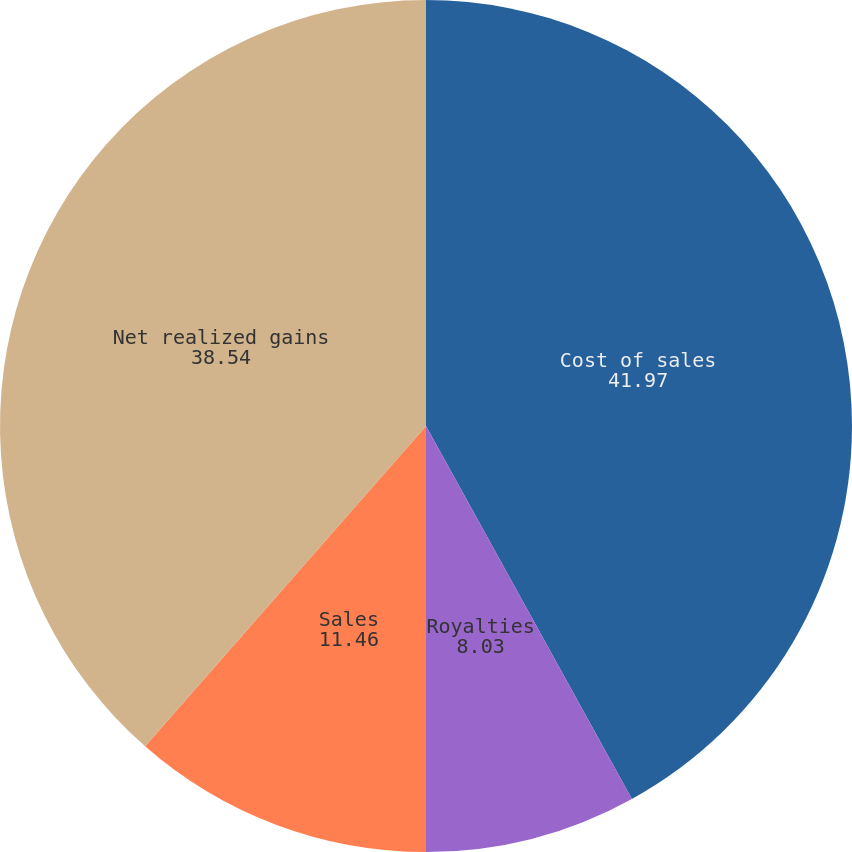Convert chart to OTSL. <chart><loc_0><loc_0><loc_500><loc_500><pie_chart><fcel>Cost of sales<fcel>Royalties<fcel>Sales<fcel>Net realized gains<nl><fcel>41.97%<fcel>8.03%<fcel>11.46%<fcel>38.54%<nl></chart> 